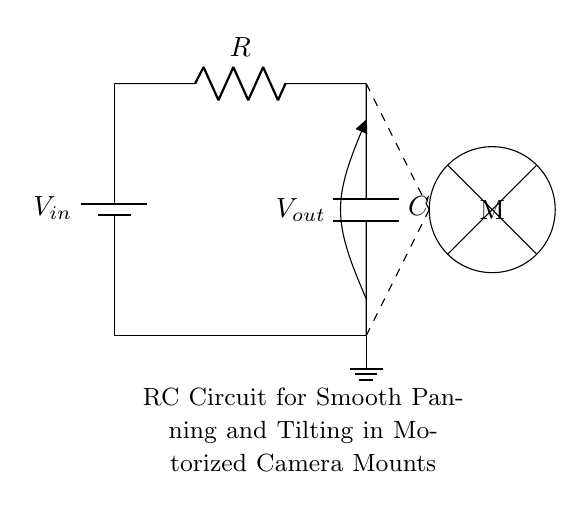What is the input voltage of the circuit? The input voltage is designated as V_in in the circuit diagram. It is represented as the voltage source on the left side of the schematic.
Answer: V_in What components are present in the circuit? The circuit contains a battery (voltage source), a resistor, a capacitor, and a motor. Each component is clearly labeled in the diagram, depicting their arrangement and functions.
Answer: Battery, resistor, capacitor, motor What is the function of the capacitor in this circuit? The capacitor in this RC circuit serves to smoothen the output voltage, allowing for a gradual change in voltage across the motor, which ensures smooth panning and tilting.
Answer: Smoothing output voltage How does the resistor influence the charging time of the capacitor? The resistor limits the current flowing into the capacitor, thereby affecting the time constant (τ = R * C) of the charging process. A higher resistance results in a longer charging time, and vice versa.
Answer: It controls charging time What is the relationship between resistance and capacitance in determining circuit behavior? The combination of resistance (R) and capacitance (C) dictates the time constant (τ) of the circuit which determines how quickly or slowly the capacitor charges or discharges, impacting the motor’s response time.
Answer: Time constant Where is the output voltage measured in the circuit? The output voltage (V_out) is measured from the junction between the resistor and the capacitor down to ground, which indicates the voltage across the capacitor and the motor.
Answer: Across the capacitor What is the purpose of the dashed lines in the diagram? The dashed lines represent the connections from the RC circuit to the motor, indicating that the output voltage affects the motor's operation while separating these two sections visually.
Answer: Connection to motor 